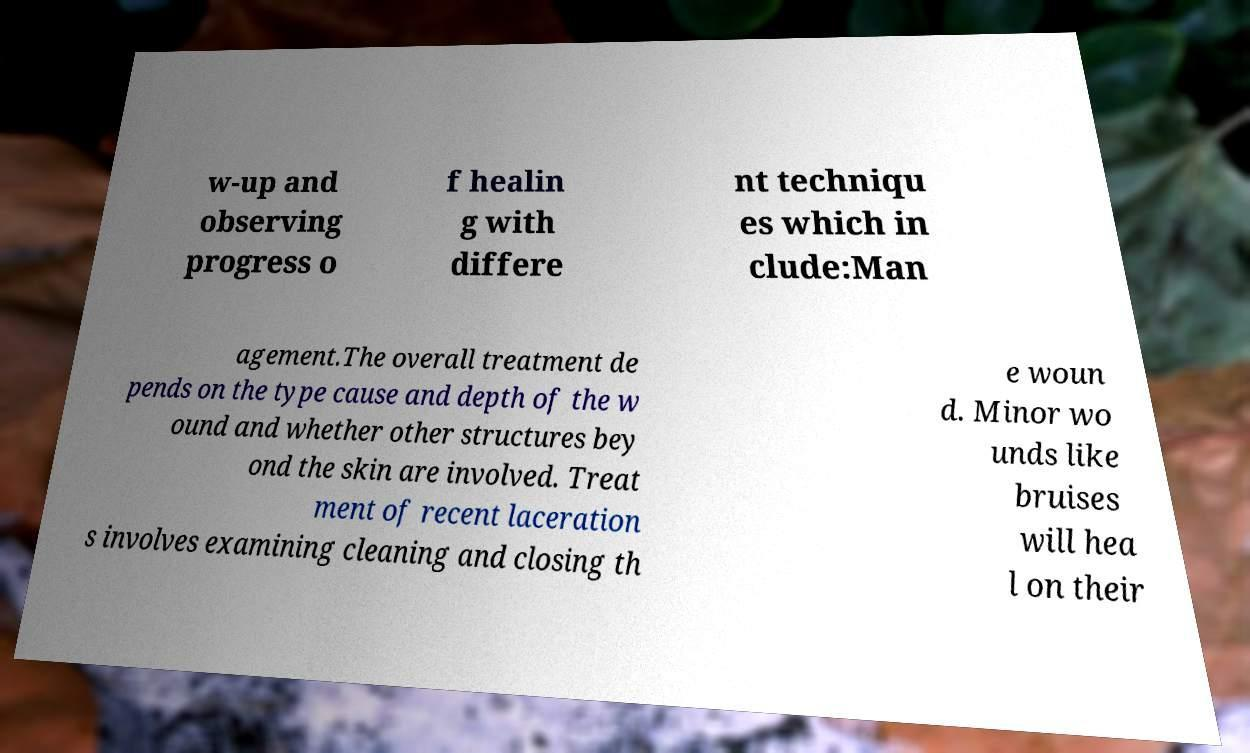There's text embedded in this image that I need extracted. Can you transcribe it verbatim? w-up and observing progress o f healin g with differe nt techniqu es which in clude:Man agement.The overall treatment de pends on the type cause and depth of the w ound and whether other structures bey ond the skin are involved. Treat ment of recent laceration s involves examining cleaning and closing th e woun d. Minor wo unds like bruises will hea l on their 